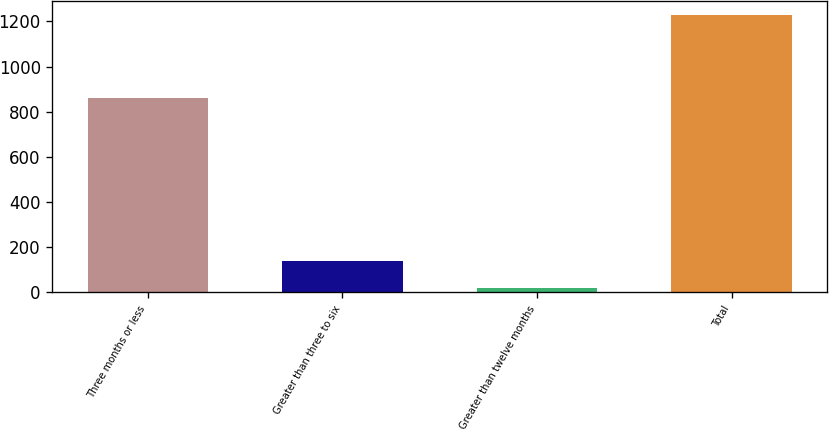Convert chart. <chart><loc_0><loc_0><loc_500><loc_500><bar_chart><fcel>Three months or less<fcel>Greater than three to six<fcel>Greater than twelve months<fcel>Total<nl><fcel>859<fcel>139.1<fcel>18<fcel>1229<nl></chart> 